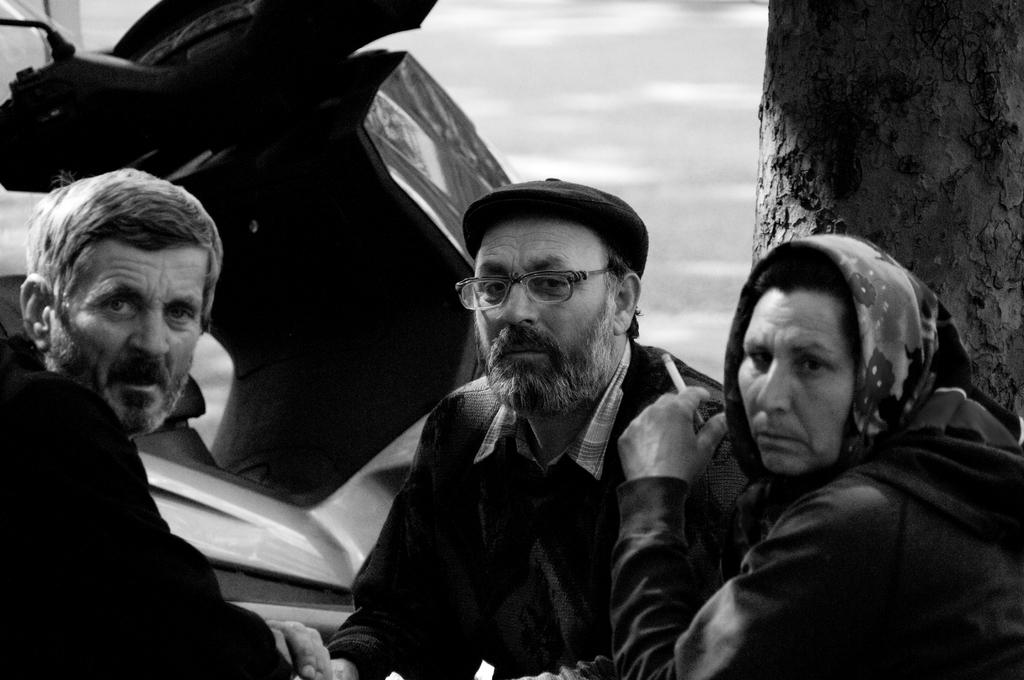What is the color scheme of the image? The image is black and white. How many people are in the image? There are three persons in the image. What is one of the persons doing? One of the persons is holding a cigarette. What can be seen in the background of the image? There is a motorbike and bark (possibly from trees) in the background of the image. Where is the mailbox located in the image? There is no mailbox present in the image. What type of polish is being applied to the dolls in the image? There are no dolls or polish present in the image. 